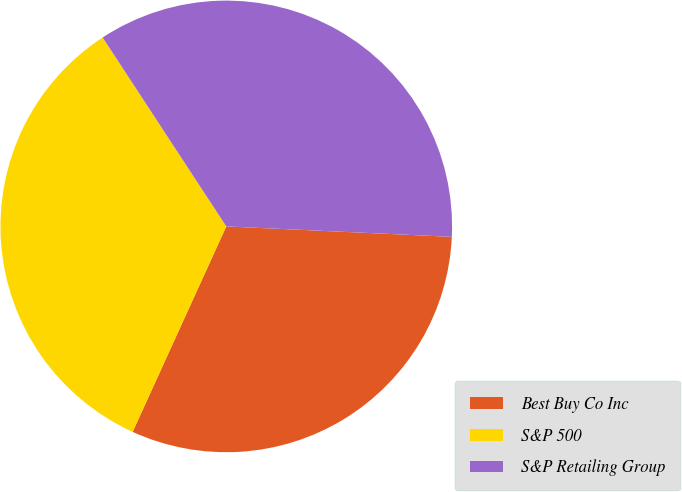Convert chart. <chart><loc_0><loc_0><loc_500><loc_500><pie_chart><fcel>Best Buy Co Inc<fcel>S&P 500<fcel>S&P Retailing Group<nl><fcel>31.07%<fcel>33.97%<fcel>34.96%<nl></chart> 